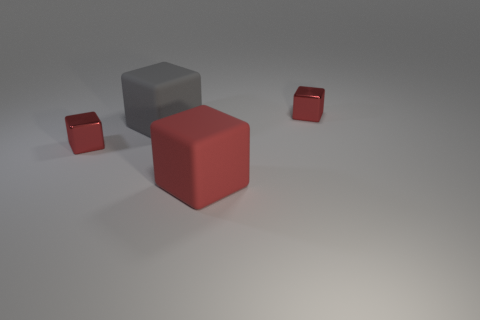Do the matte object behind the big red cube and the red matte thing have the same shape? Indeed, both objects have a cube shape. However, the object behind the big red cube is larger and has a matte grey finish, while the smaller object is red and shares the same matte texture. 